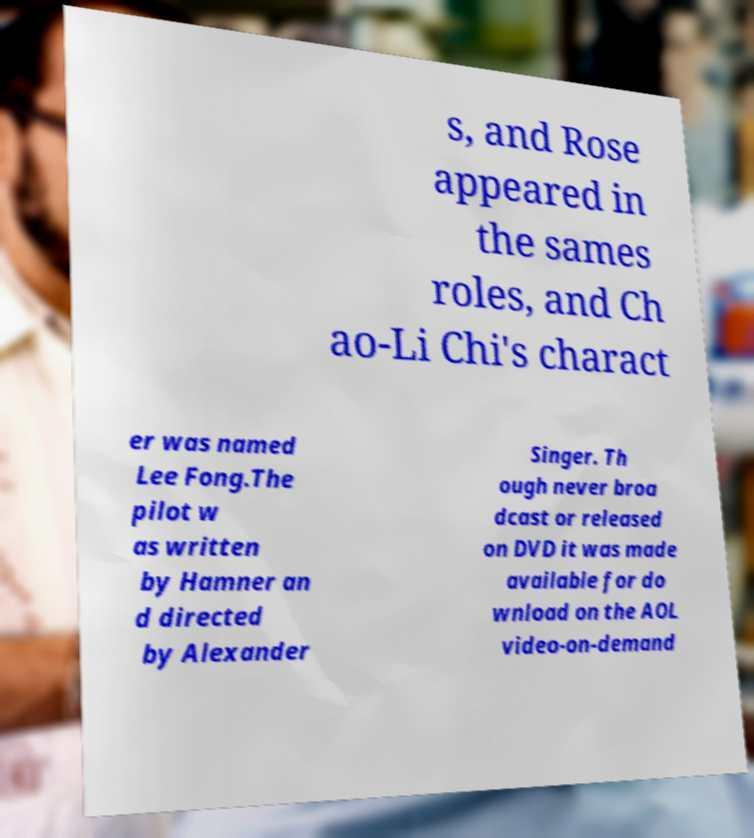Could you extract and type out the text from this image? s, and Rose appeared in the sames roles, and Ch ao-Li Chi's charact er was named Lee Fong.The pilot w as written by Hamner an d directed by Alexander Singer. Th ough never broa dcast or released on DVD it was made available for do wnload on the AOL video-on-demand 